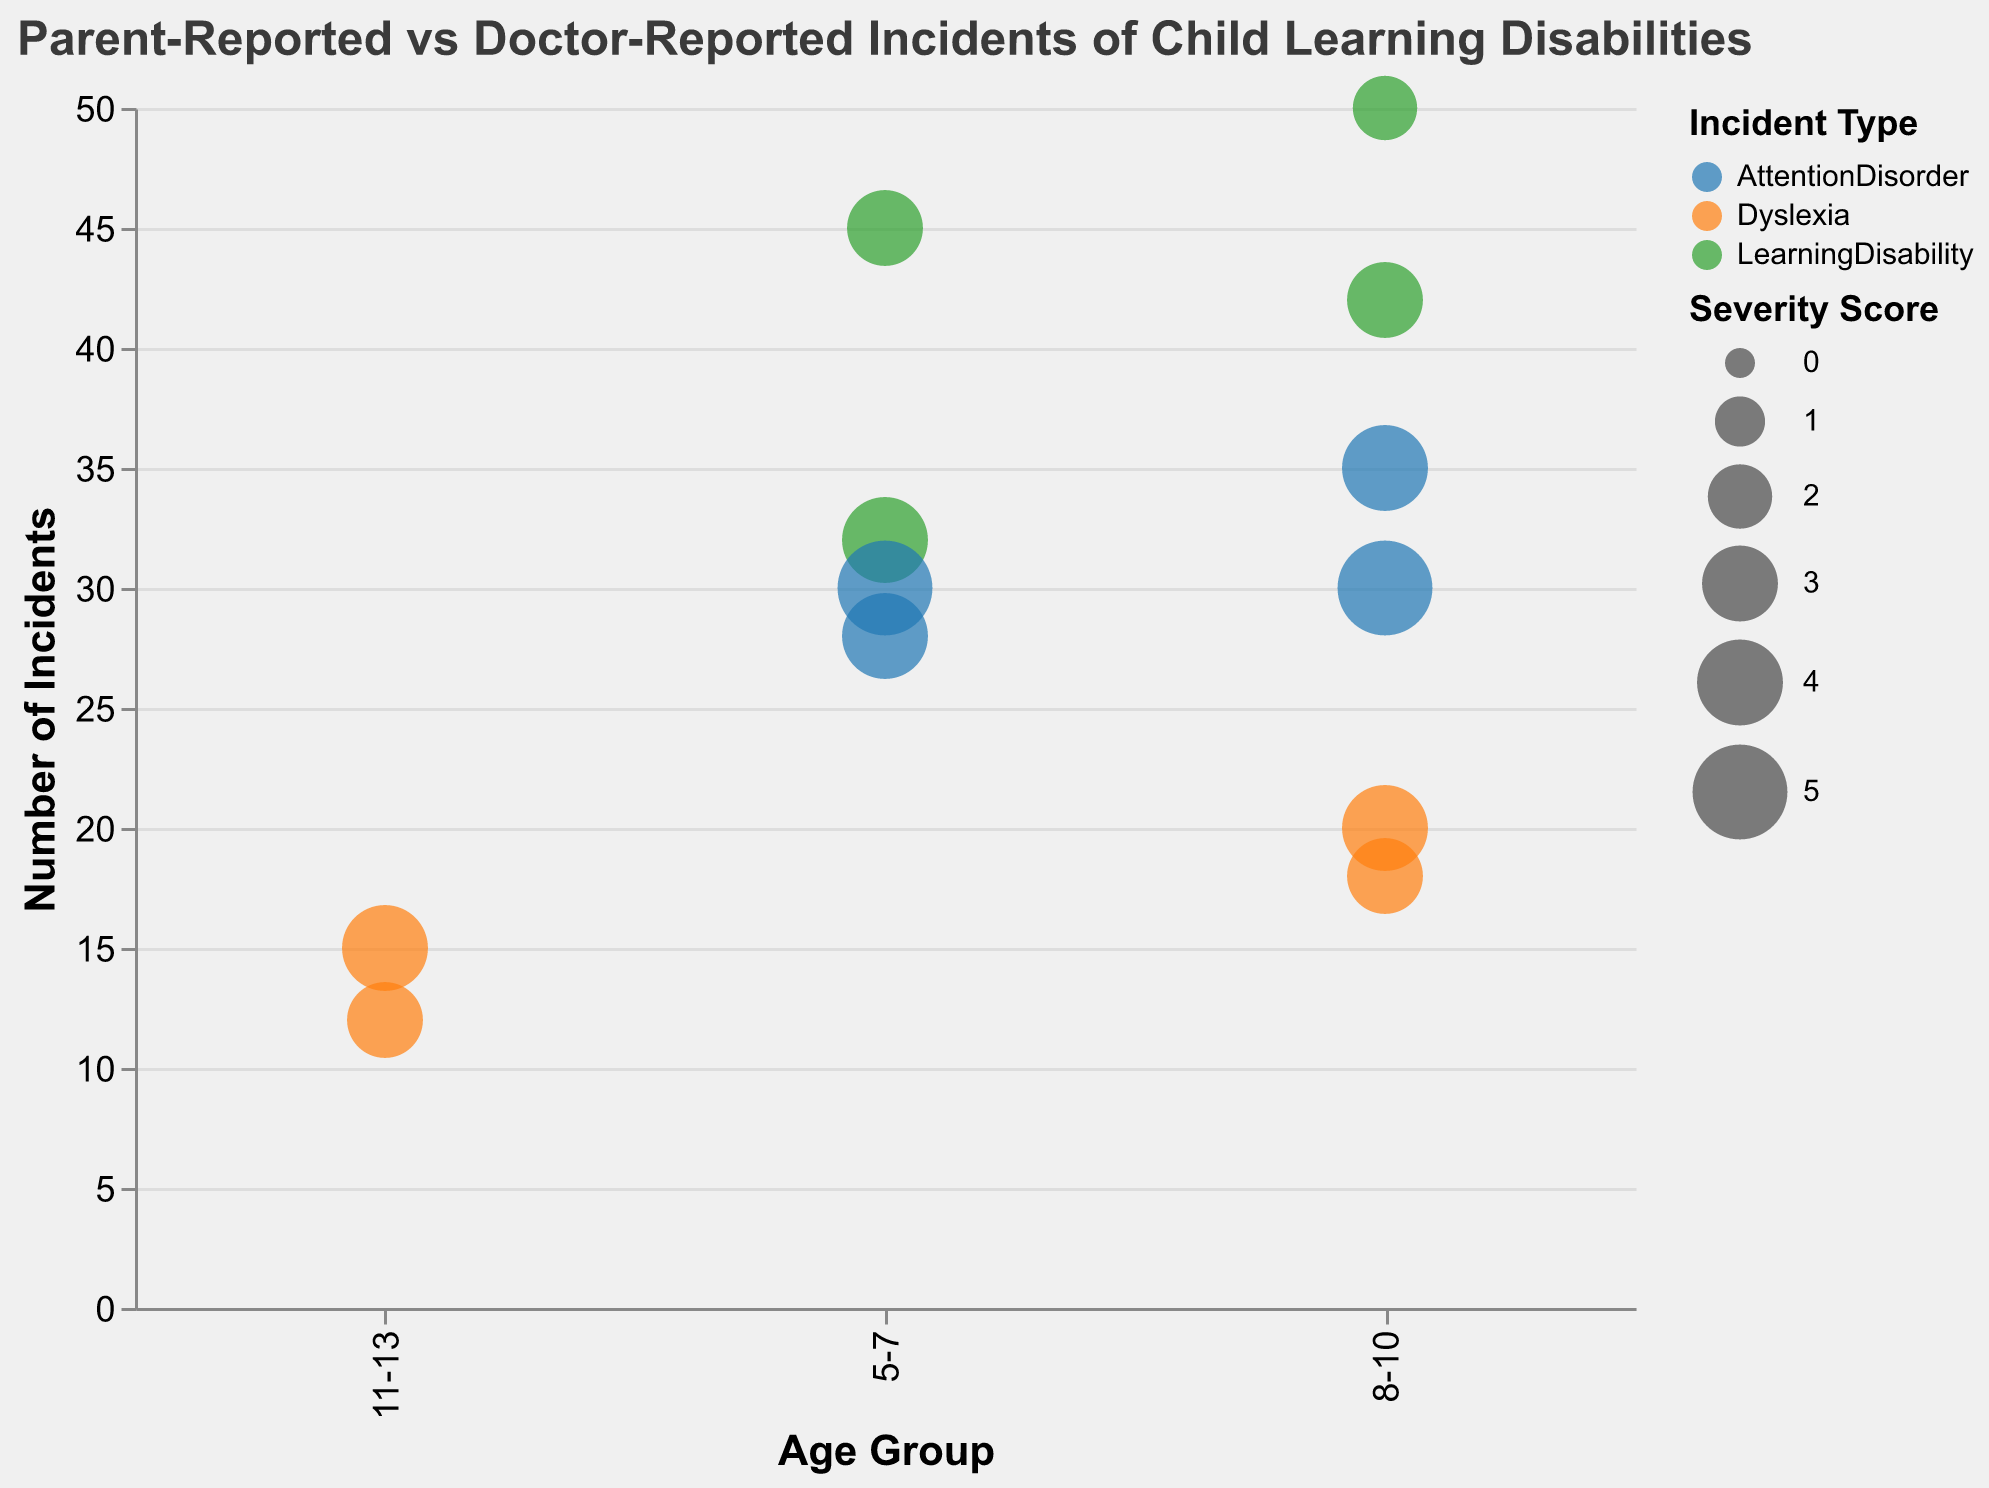What is the title of the figure? The title is located at the top of the chart and provides an overall description of the data being presented.
Answer: Parent-Reported vs Doctor-Reported Incidents of Child Learning Disabilities How many incident types are visualized in the figure? By looking at the legend that categorizes the incident types with different colors, we can see that there are three distinct incident types.
Answer: Three Which age group has the highest number of parent-reported learning disability incidents? Look at the x-axis for age groups and find the circles representing parent-reported learning disabilities, then compare the y-axis values to find the highest one.
Answer: 8-10 For the age group 5-7, which source reported a higher severity score for learning disabilities, parents or doctors? Find the bubbles representing learning disabilities for 5-7 age group, compare their sizes, which indicate severity scores, for parent-reported and doctor-reported sources.
Answer: Doctor-Reported What is the difference in the number of incidents of attention disorders reported by parents versus doctors for the age group 5-7? Look at the y-axis values for attention disorders (symbolized by circle and square) for the 5-7 age group and subtract the value for doctor-reported from parent-reported.
Answer: 2 Which incident type has the largest bubble in terms of severity score for the age group 8-10? Examine the bubble sizes within the age group 8-10 on the x-axis and identify the largest one. Check the color corresponding to the largest bubble to determine the incident type.
Answer: Attention Disorder How does the number of doctor-reported learning disability incidents for the age group 11-13 compare to that of the 8-10 age group? Locate the doctor-reported learning disabilities for both age groups and compare their y-axis values directly.
Answer: The 8-10 age group has more incidents What is the average number of parent-reported dyslexia incidents across all age groups? Identify the y-axis values for parent-reported dyslexia in all age groups, sum them up, and divide by the number of age groups reported (2 age groups).
Answer: (20 + 15) / 2 = 17.5 Which source reports a higher severity score for attention disorders in the age group 8-10? Compare the sizes of the circles and squares representing attention disorders for age group 8-10 to determine which source has a larger severity score.
Answer: Doctor-Reported What is the total number of doctor-reported incidents for all incident types in the age group 11-13? Add the y-axis values of all doctor-reported incidents for age group 11-13 to get the total.
Answer: 12 (Dyslexia only) 